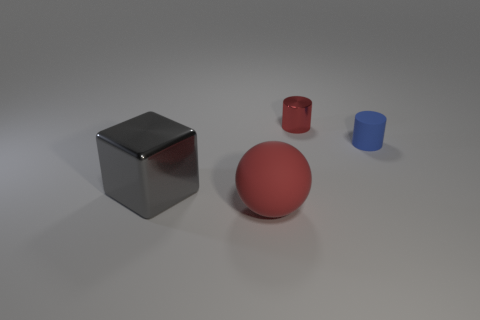Is the gray shiny object the same shape as the big red object?
Your answer should be very brief. No. Is there anything else that has the same material as the large block?
Give a very brief answer. Yes. What number of matte things are both in front of the tiny blue object and to the right of the red shiny object?
Offer a terse response. 0. There is a cylinder that is to the left of the object right of the red shiny cylinder; what is its color?
Make the answer very short. Red. Is the number of things that are in front of the large red matte sphere the same as the number of small cyan metallic cylinders?
Ensure brevity in your answer.  Yes. How many blue objects are in front of the tiny object that is right of the red thing that is behind the large red rubber thing?
Provide a short and direct response. 0. What is the color of the tiny cylinder on the right side of the tiny metal object?
Ensure brevity in your answer.  Blue. There is a object that is in front of the small blue object and right of the large gray shiny cube; what material is it?
Keep it short and to the point. Rubber. What number of gray cubes are behind the metal thing on the left side of the small red cylinder?
Ensure brevity in your answer.  0. What is the shape of the big matte thing?
Your response must be concise. Sphere. 